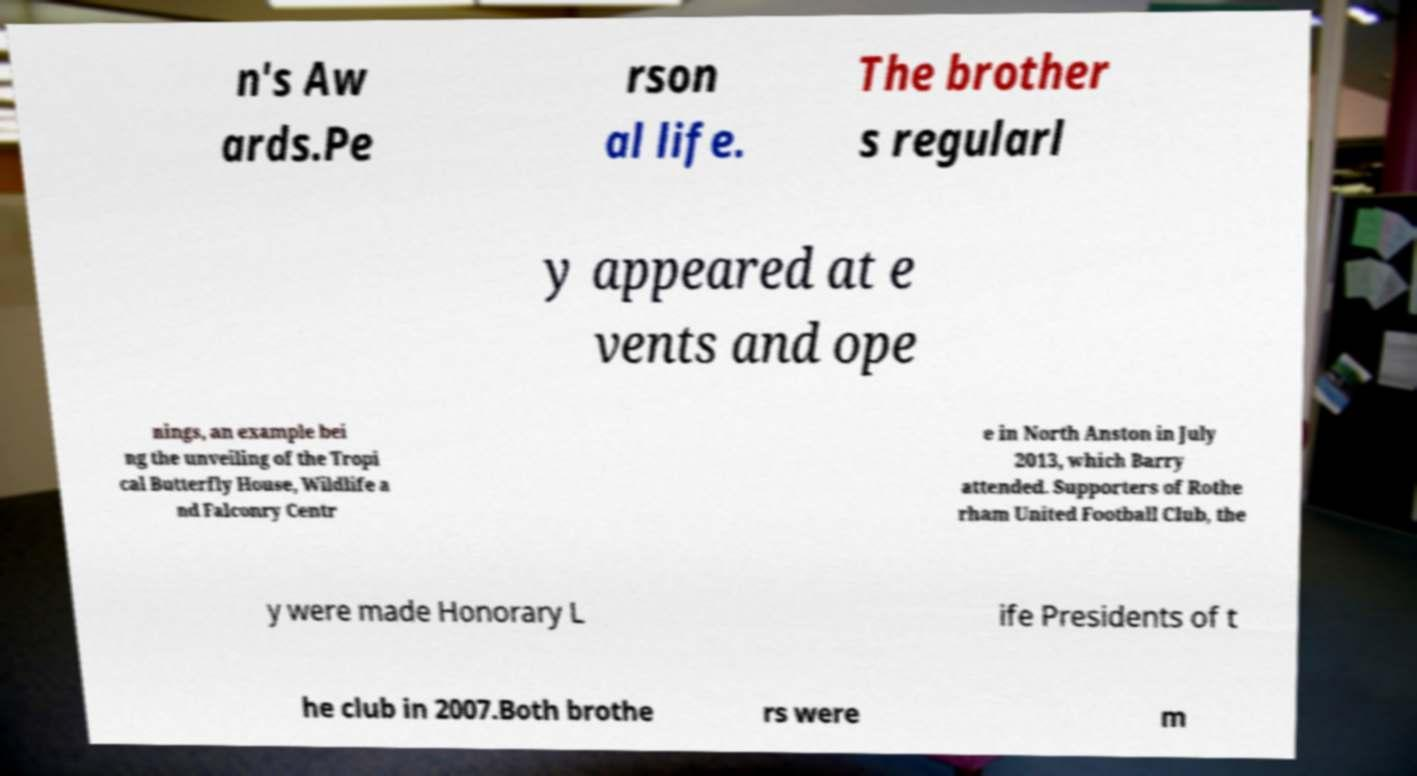For documentation purposes, I need the text within this image transcribed. Could you provide that? n's Aw ards.Pe rson al life. The brother s regularl y appeared at e vents and ope nings, an example bei ng the unveiling of the Tropi cal Butterfly House, Wildlife a nd Falconry Centr e in North Anston in July 2013, which Barry attended. Supporters of Rothe rham United Football Club, the y were made Honorary L ife Presidents of t he club in 2007.Both brothe rs were m 